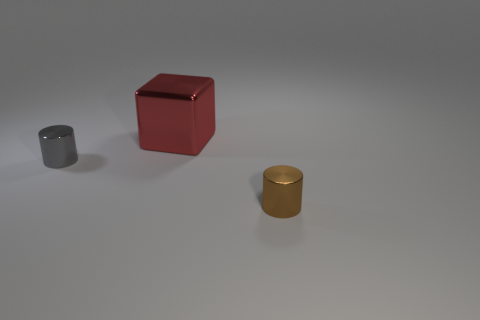Add 3 small brown metal things. How many objects exist? 6 Subtract all cylinders. How many objects are left? 1 Add 1 tiny gray metallic cylinders. How many tiny gray metallic cylinders are left? 2 Add 2 large purple shiny things. How many large purple shiny things exist? 2 Subtract 0 blue balls. How many objects are left? 3 Subtract all brown metal objects. Subtract all big red metallic blocks. How many objects are left? 1 